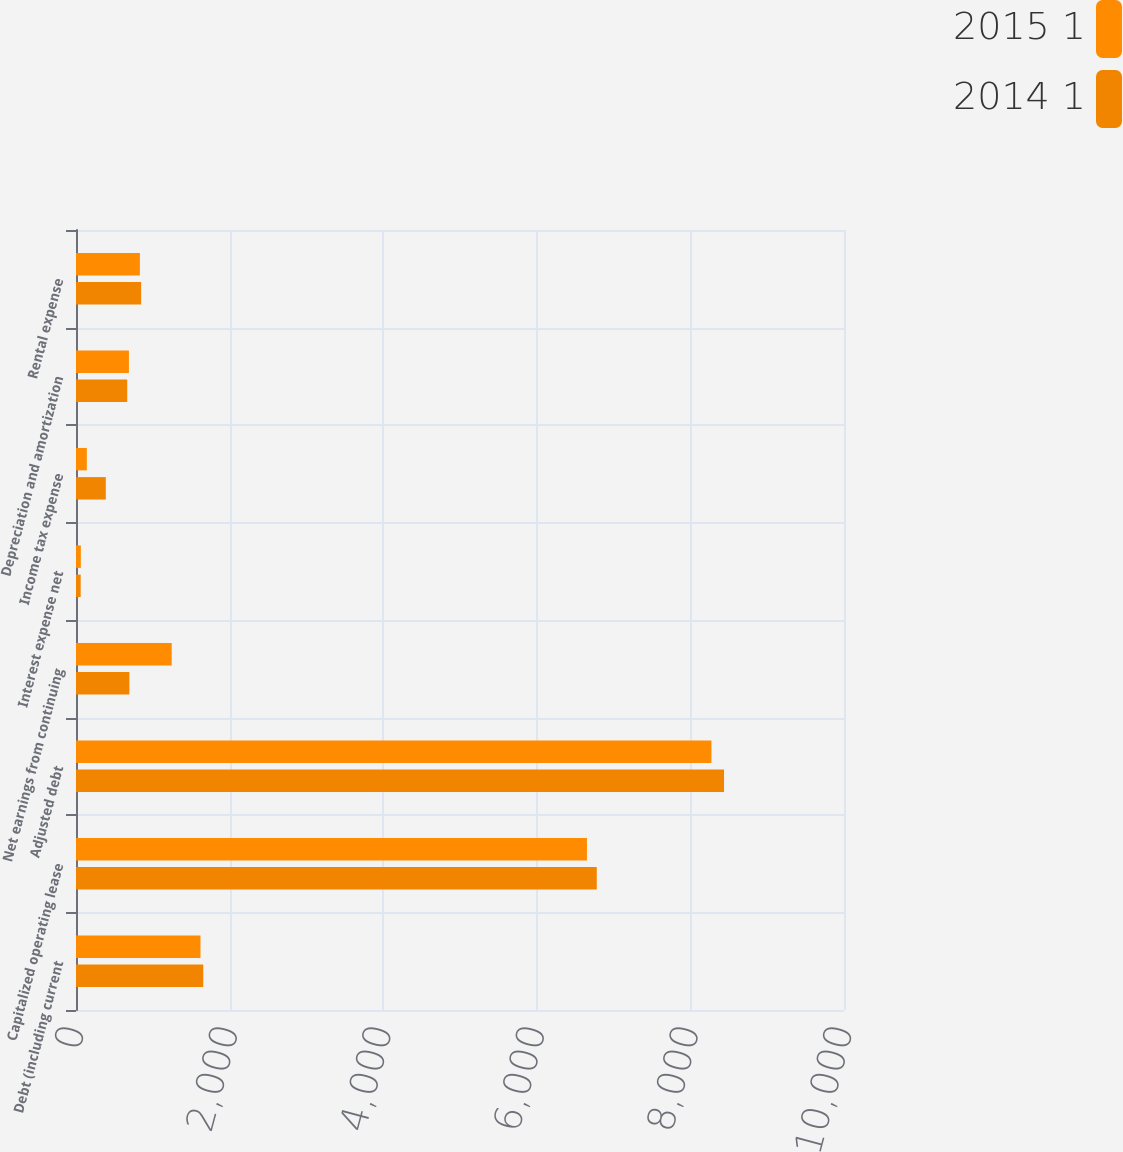Convert chart. <chart><loc_0><loc_0><loc_500><loc_500><stacked_bar_chart><ecel><fcel>Debt (including current<fcel>Capitalized operating lease<fcel>Adjusted debt<fcel>Net earnings from continuing<fcel>Interest expense net<fcel>Income tax expense<fcel>Depreciation and amortization<fcel>Rental expense<nl><fcel>2015 1<fcel>1621<fcel>6653<fcel>8274<fcel>1246<fcel>63<fcel>141<fcel>689<fcel>832<nl><fcel>2014 1<fcel>1657<fcel>6781<fcel>8438<fcel>695<fcel>61<fcel>388<fcel>667<fcel>848<nl></chart> 